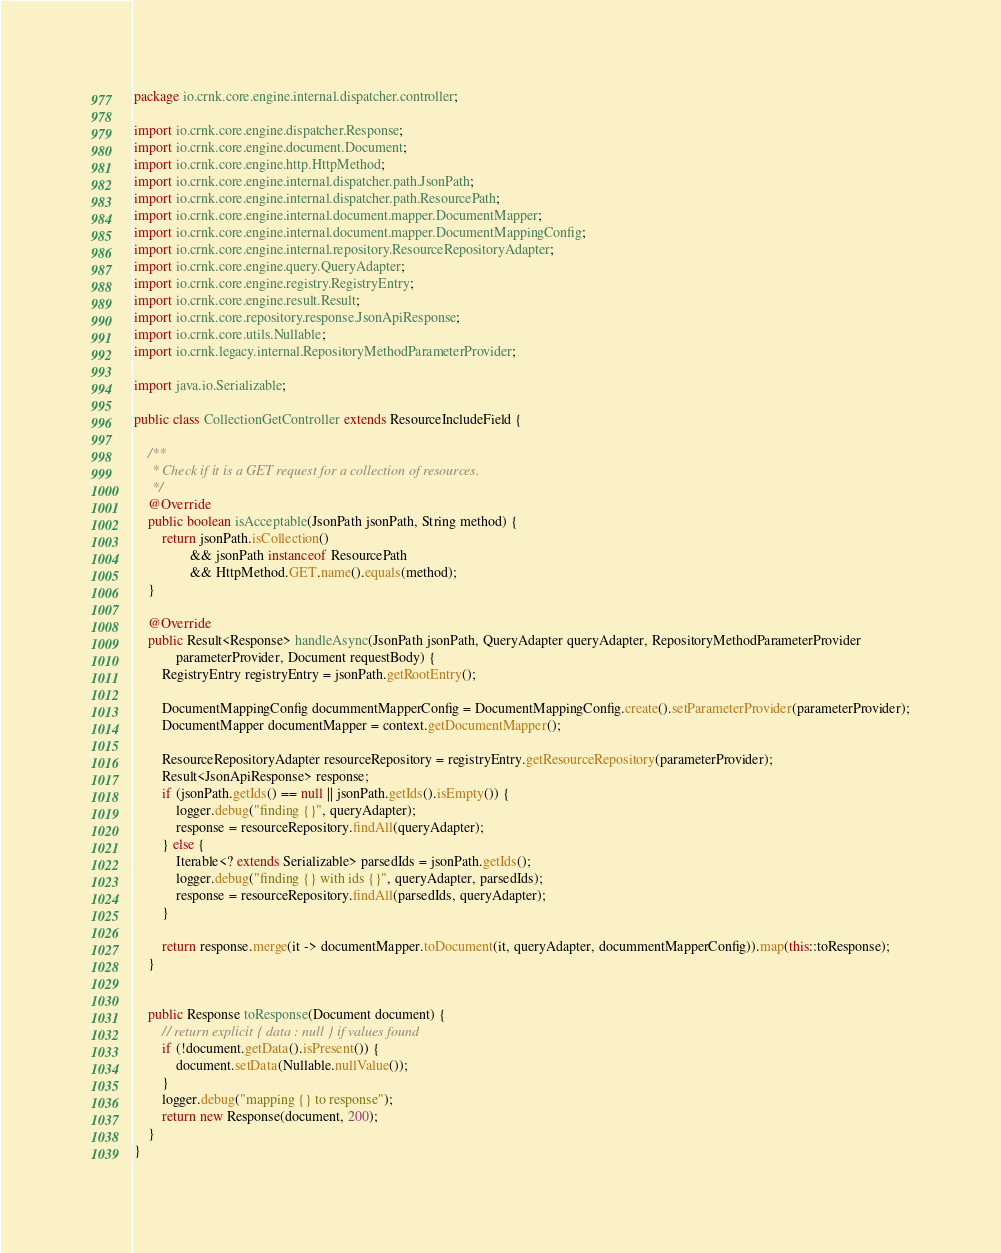<code> <loc_0><loc_0><loc_500><loc_500><_Java_>package io.crnk.core.engine.internal.dispatcher.controller;

import io.crnk.core.engine.dispatcher.Response;
import io.crnk.core.engine.document.Document;
import io.crnk.core.engine.http.HttpMethod;
import io.crnk.core.engine.internal.dispatcher.path.JsonPath;
import io.crnk.core.engine.internal.dispatcher.path.ResourcePath;
import io.crnk.core.engine.internal.document.mapper.DocumentMapper;
import io.crnk.core.engine.internal.document.mapper.DocumentMappingConfig;
import io.crnk.core.engine.internal.repository.ResourceRepositoryAdapter;
import io.crnk.core.engine.query.QueryAdapter;
import io.crnk.core.engine.registry.RegistryEntry;
import io.crnk.core.engine.result.Result;
import io.crnk.core.repository.response.JsonApiResponse;
import io.crnk.core.utils.Nullable;
import io.crnk.legacy.internal.RepositoryMethodParameterProvider;

import java.io.Serializable;

public class CollectionGetController extends ResourceIncludeField {

	/**
	 * Check if it is a GET request for a collection of resources.
	 */
	@Override
	public boolean isAcceptable(JsonPath jsonPath, String method) {
		return jsonPath.isCollection()
				&& jsonPath instanceof ResourcePath
				&& HttpMethod.GET.name().equals(method);
	}

	@Override
	public Result<Response> handleAsync(JsonPath jsonPath, QueryAdapter queryAdapter, RepositoryMethodParameterProvider
			parameterProvider, Document requestBody) {
		RegistryEntry registryEntry = jsonPath.getRootEntry();

		DocumentMappingConfig docummentMapperConfig = DocumentMappingConfig.create().setParameterProvider(parameterProvider);
		DocumentMapper documentMapper = context.getDocumentMapper();

		ResourceRepositoryAdapter resourceRepository = registryEntry.getResourceRepository(parameterProvider);
		Result<JsonApiResponse> response;
		if (jsonPath.getIds() == null || jsonPath.getIds().isEmpty()) {
			logger.debug("finding {}", queryAdapter);
			response = resourceRepository.findAll(queryAdapter);
		} else {
			Iterable<? extends Serializable> parsedIds = jsonPath.getIds();
			logger.debug("finding {} with ids {}", queryAdapter, parsedIds);
			response = resourceRepository.findAll(parsedIds, queryAdapter);
		}

		return response.merge(it -> documentMapper.toDocument(it, queryAdapter, docummentMapperConfig)).map(this::toResponse);
	}


	public Response toResponse(Document document) {
		// return explicit { data : null } if values found
		if (!document.getData().isPresent()) {
			document.setData(Nullable.nullValue());
		}
		logger.debug("mapping {} to response");
		return new Response(document, 200);
	}
}
</code> 